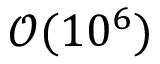<formula> <loc_0><loc_0><loc_500><loc_500>\mathcal { O } ( 1 0 ^ { 6 } )</formula> 